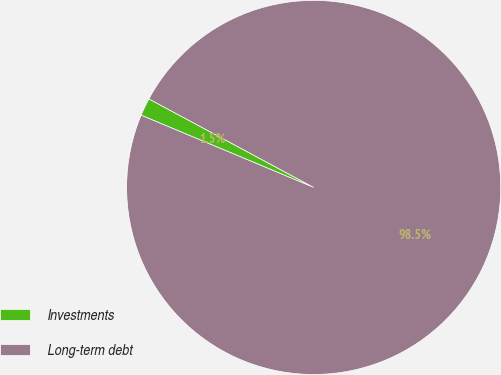Convert chart. <chart><loc_0><loc_0><loc_500><loc_500><pie_chart><fcel>Investments<fcel>Long-term debt<nl><fcel>1.54%<fcel>98.46%<nl></chart> 